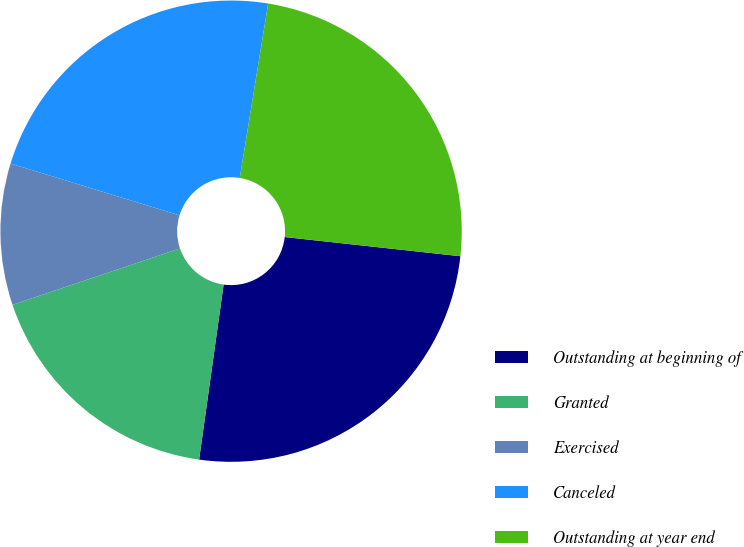<chart> <loc_0><loc_0><loc_500><loc_500><pie_chart><fcel>Outstanding at beginning of<fcel>Granted<fcel>Exercised<fcel>Canceled<fcel>Outstanding at year end<nl><fcel>25.48%<fcel>17.61%<fcel>9.91%<fcel>22.83%<fcel>24.16%<nl></chart> 